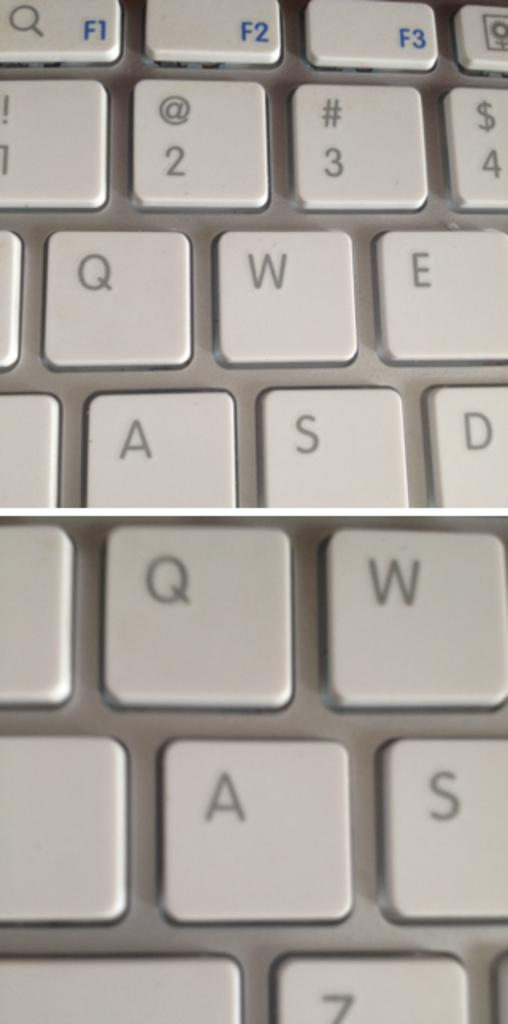<image>
Render a clear and concise summary of the photo. Various keyboard keys are visible, such as F1, F2 and F3. 